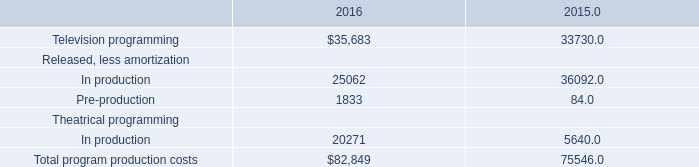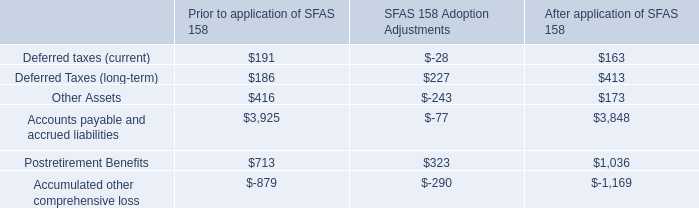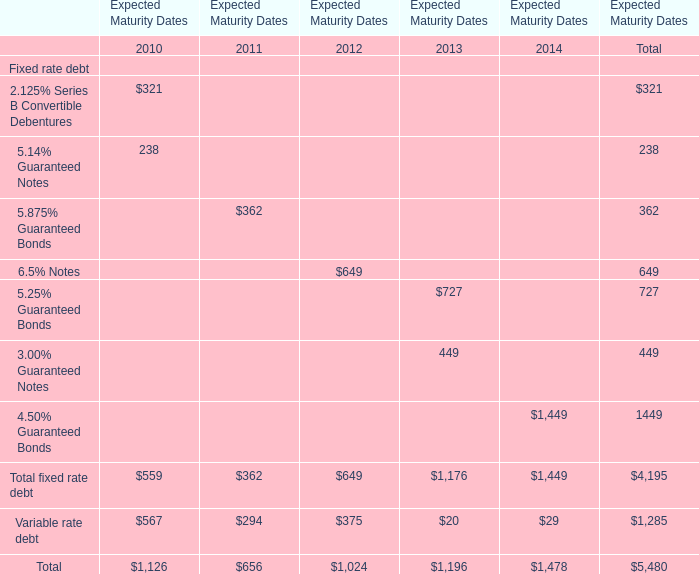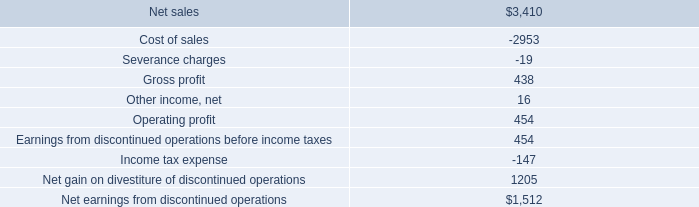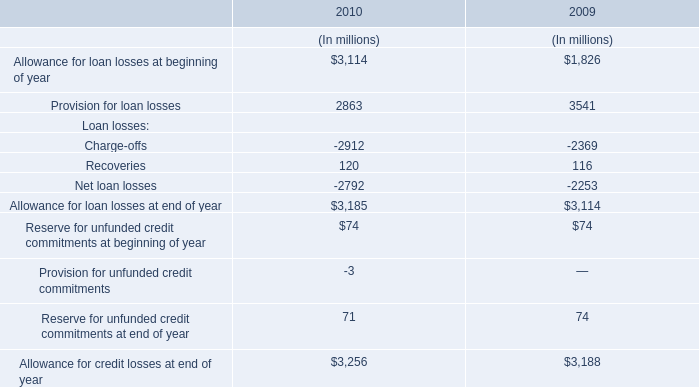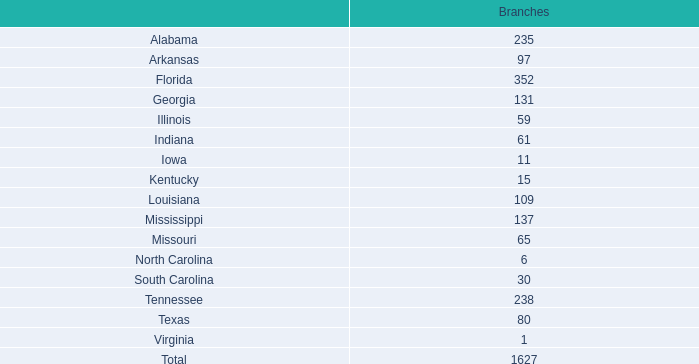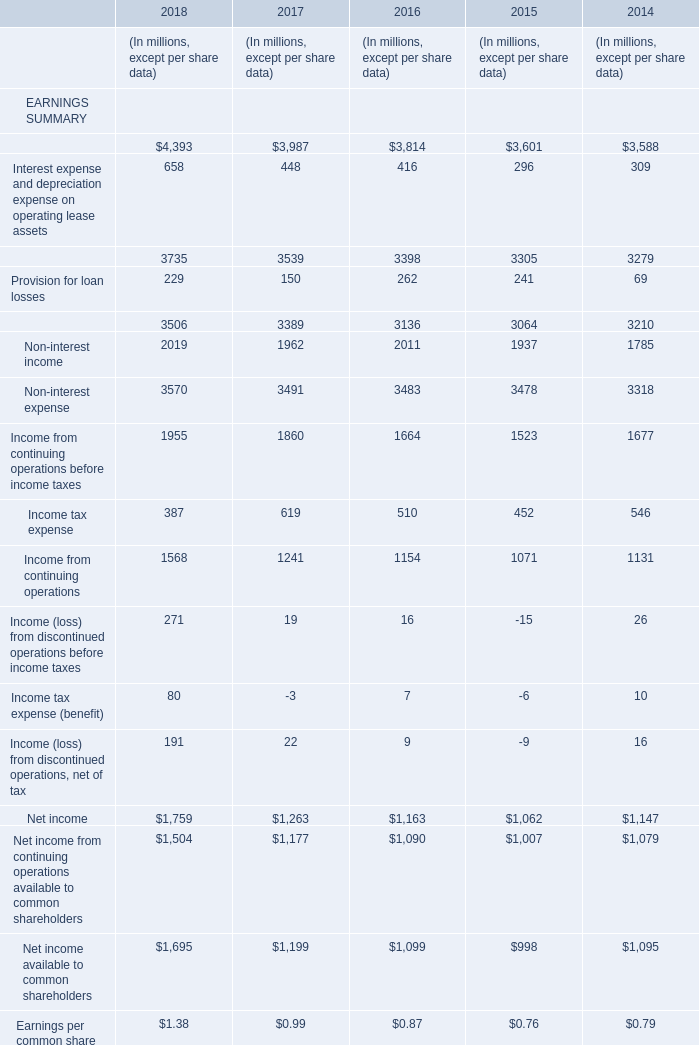In the year with lowest amount of Net income, what's the increasing rate of Non-interest expense? 
Computations: ((3478 - 3318) / 3318)
Answer: 0.04822. 